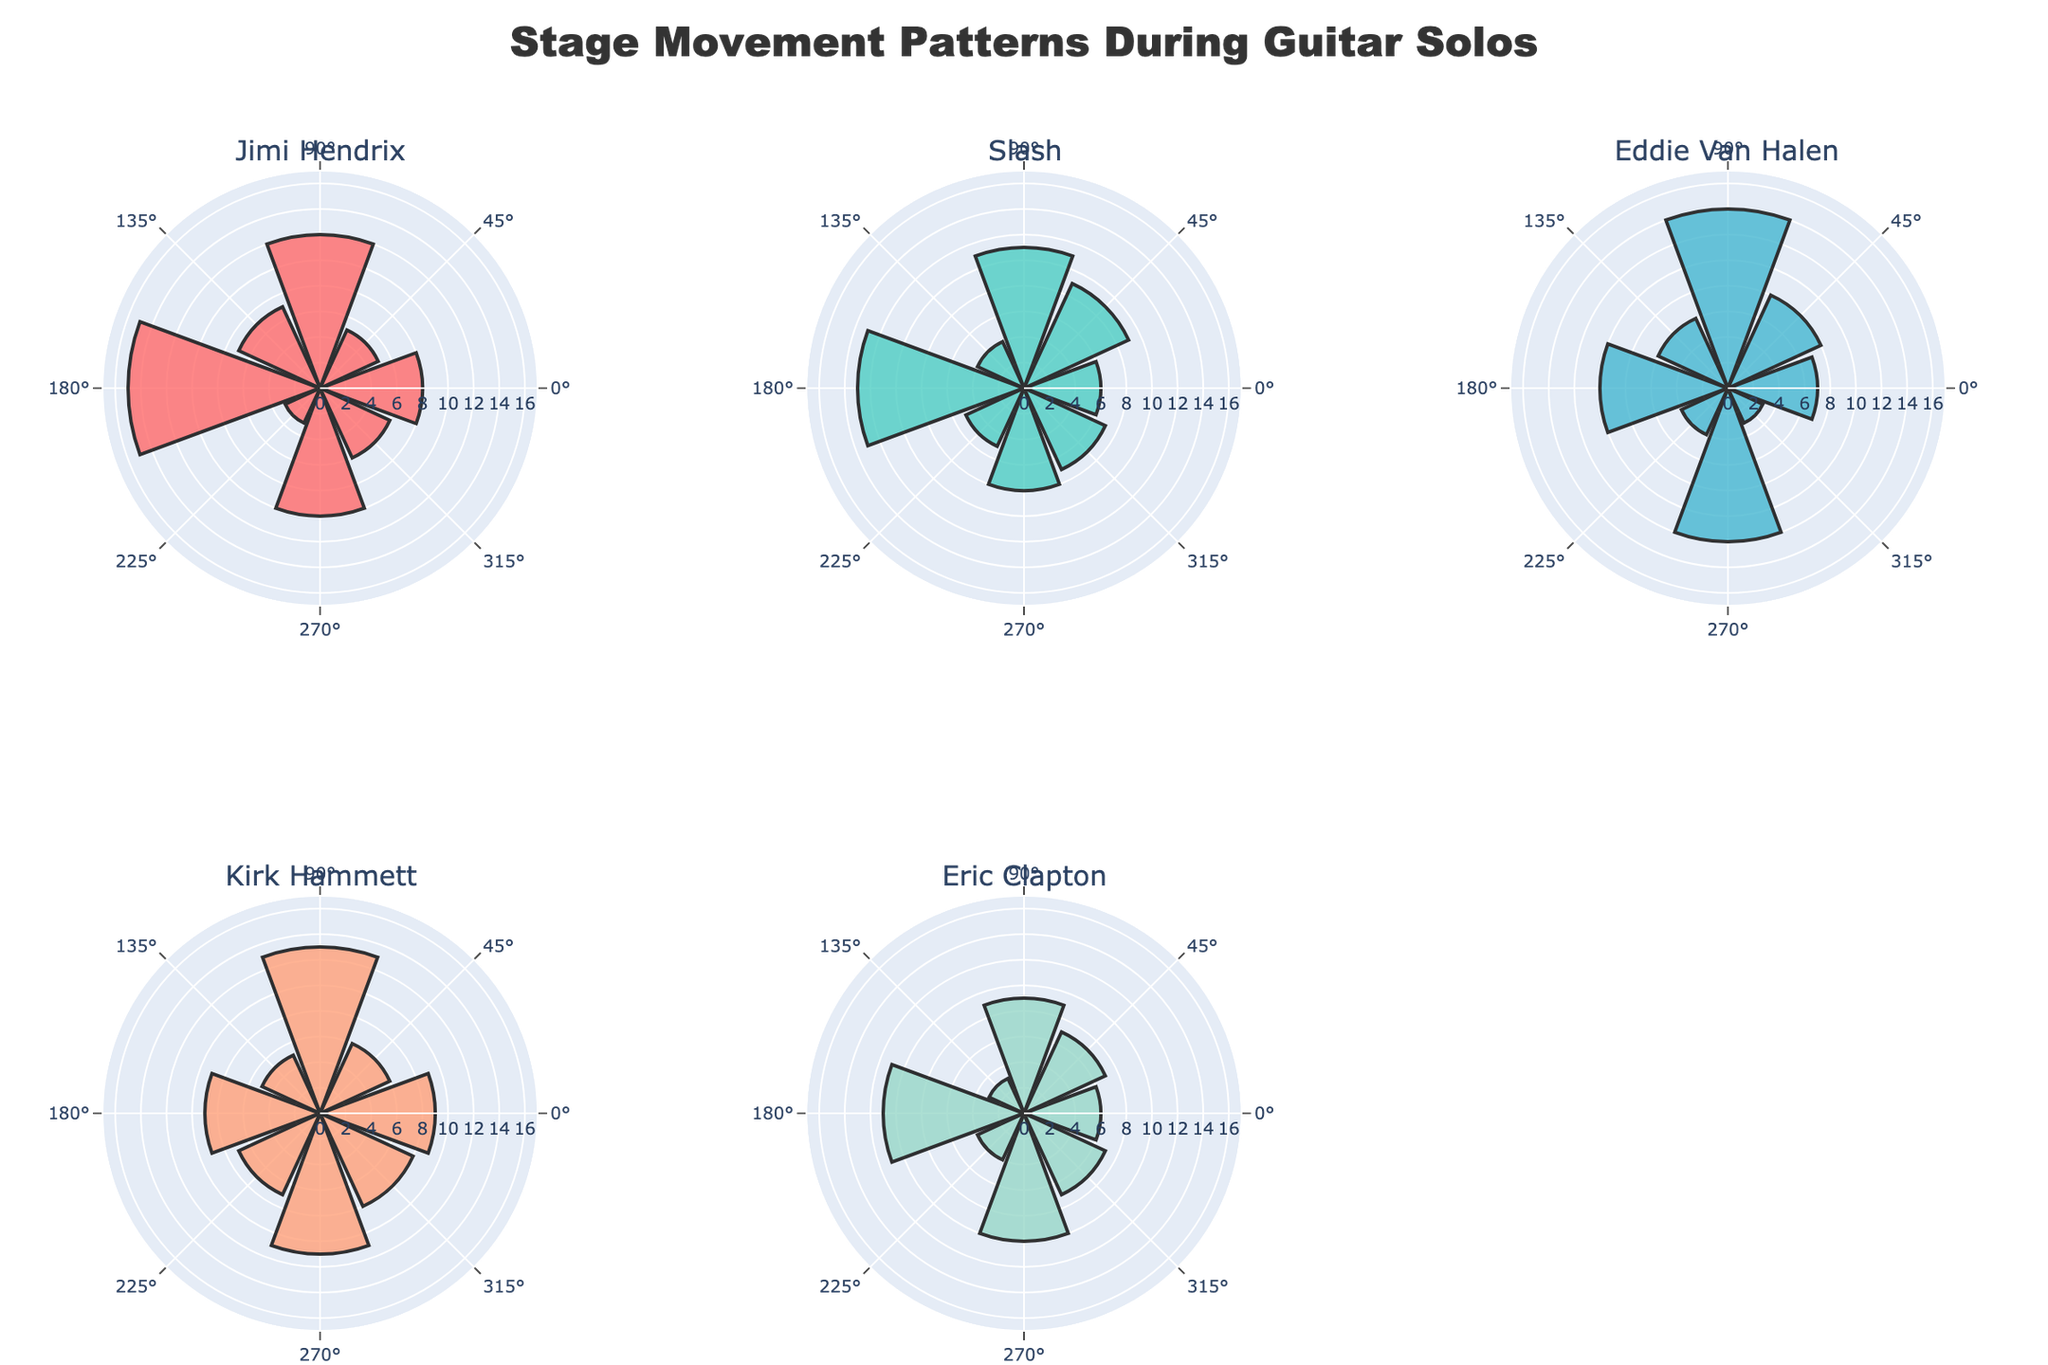What's the title of the figure? Look at the text at the top of the figure positioned in the center, which provides the title.
Answer: Stage Movement Patterns During Guitar Solos How many performers' movements are analyzed in the figure? Count the number of subplot titles, each representing a performer. There are 5 titles displayed, suggesting 5 performers.
Answer: 5 Which performer has the highest movement frequency at 90 degrees? Examine each of the subplot bars at 90 degrees and find the highest bar. Eddie Van Halen has the highest frequency at this angle.
Answer: Eddie Van Halen What is the color of Slash's chart? Identify the unique color of the subplot corresponding to Slash among the five subplots. The color is a shade of green.
Answer: Green What's the combined movement frequency for Jimi Hendrix at 0 and 180 degrees? Look at Jimi Hendrix's subplot and find the frequencies at 0 and 180 degrees. Sum them up: 8 (0 degrees) + 15 (180 degrees) = 23.
Answer: 23 Which performer shows the least movement frequency at 135 degrees? Check each performer’s subplot for the bar at 135 degrees and note the lowest. Eric Clapton has the lowest frequency at this angle.
Answer: Eric Clapton How does Kirk Hammett's movement frequency at 270 degrees compare to Eric Clapton's at the same angle? Compare the heights of the bars at 270 degrees in Kirk Hammett’s and Eric Clapton’s subplots. Kirk Hammett has a frequency of 11, while Eric Clapton has 10 at 270 degrees.
Answer: Kirk Hammett's is higher What is the average frequency of stage movements for Eddie Van Halen at all angles? Sum all frequencies for Eddie Van Halen and divide by the number of angles: (7+8+14+6+10+4+12+3) / 8 = 64 / 8 = 8.
Answer: 8 Which performer has the most balanced movement frequencies across all angles? Identify which subplot shows relatively even bar heights (bars of similar length) across angles. Eric Clapton’s chart displays a more balanced distribution compared to others.
Answer: Eric Clapton Which angle has the most frequent movement for Slash? Look at Slash's subplot and identify the tallest bar, which is at 180 degrees with a frequency of 13.
Answer: 180 degrees 